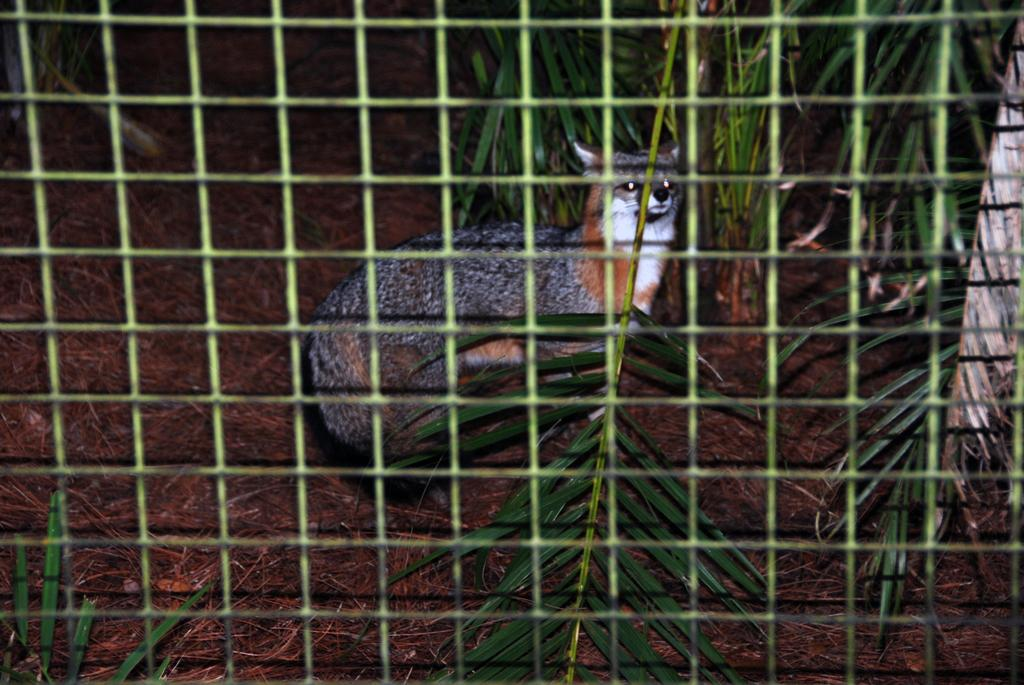What type of living creature is in the image? There is an animal in the image. What other elements can be seen in the image besides the animal? There are plants and a fence in the image. What type of art can be seen hanging on the fence in the image? There is no art present in the image; it only features an animal, plants, and a fence. 